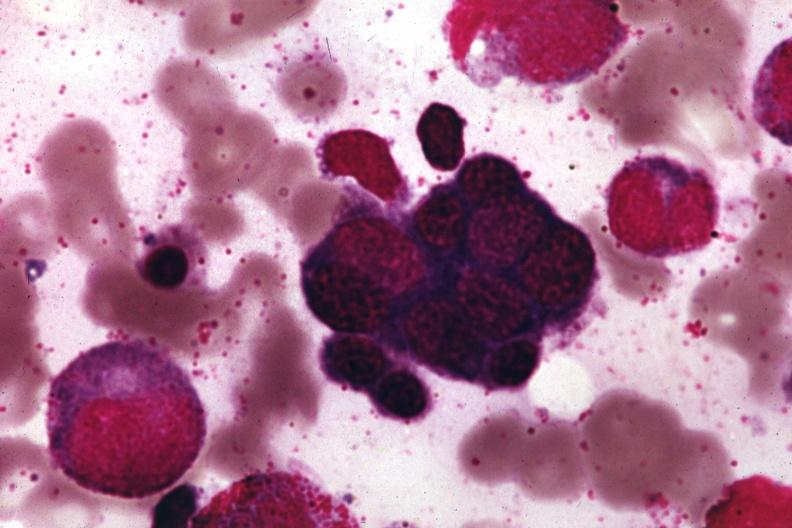s lateral view of infants present?
Answer the question using a single word or phrase. No 